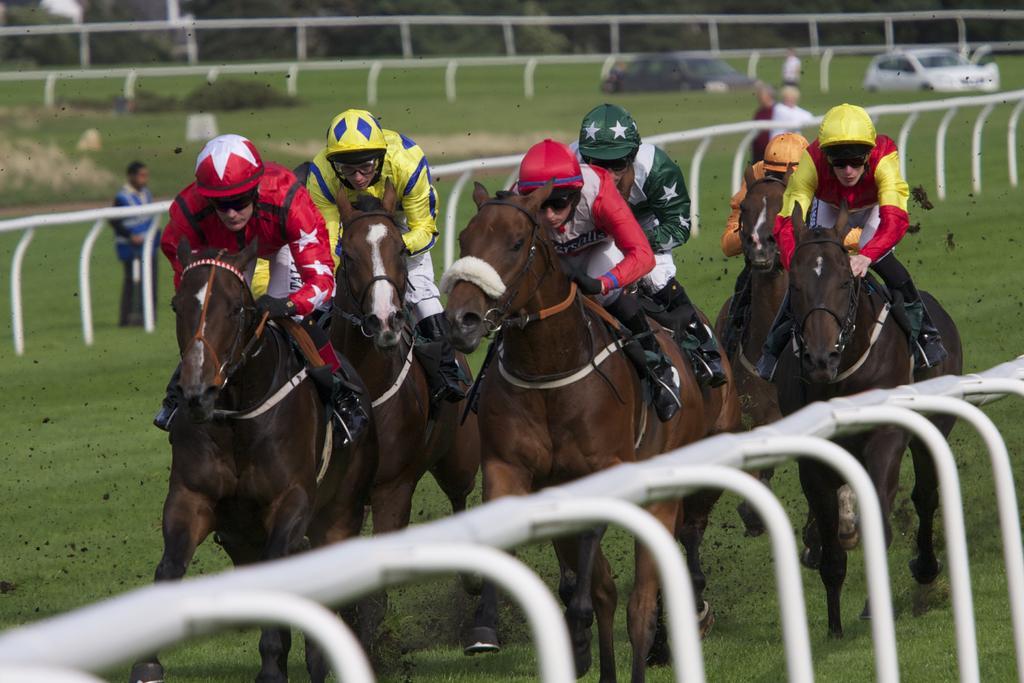In one or two sentences, can you explain what this image depicts? In the foreground I can see five persons are riding a horse on the ground and a fence. In the background I can see a group of people and vehicles on the ground. On the top I can see trees. This image is taken during a day on the ground. 